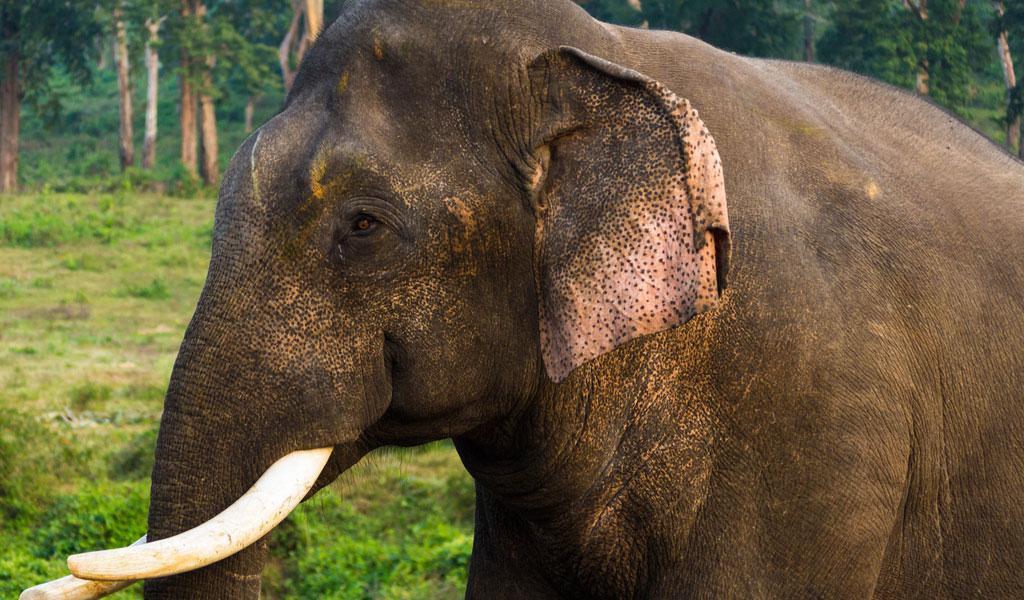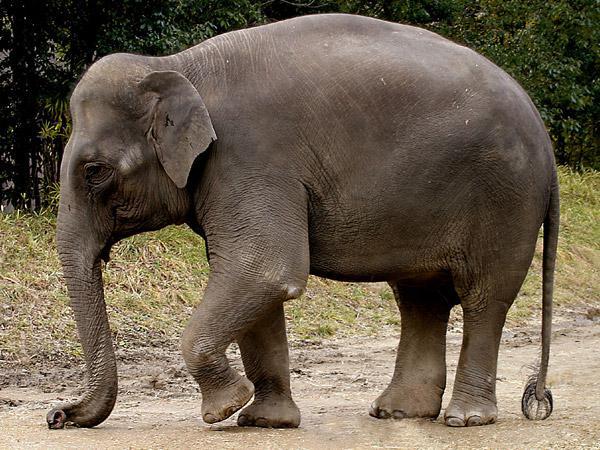The first image is the image on the left, the second image is the image on the right. Given the left and right images, does the statement "Three elephants walk together in the image on the left." hold true? Answer yes or no. No. The first image is the image on the left, the second image is the image on the right. For the images shown, is this caption "One image includes leftward-facing adult and young elephants." true? Answer yes or no. No. 